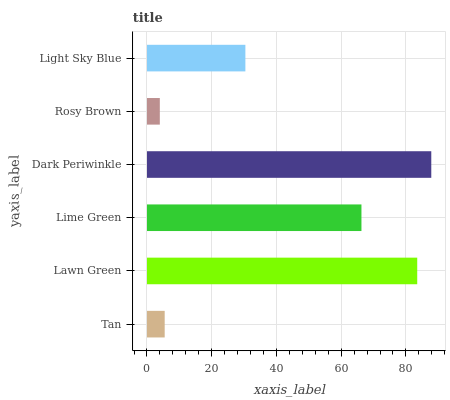Is Rosy Brown the minimum?
Answer yes or no. Yes. Is Dark Periwinkle the maximum?
Answer yes or no. Yes. Is Lawn Green the minimum?
Answer yes or no. No. Is Lawn Green the maximum?
Answer yes or no. No. Is Lawn Green greater than Tan?
Answer yes or no. Yes. Is Tan less than Lawn Green?
Answer yes or no. Yes. Is Tan greater than Lawn Green?
Answer yes or no. No. Is Lawn Green less than Tan?
Answer yes or no. No. Is Lime Green the high median?
Answer yes or no. Yes. Is Light Sky Blue the low median?
Answer yes or no. Yes. Is Tan the high median?
Answer yes or no. No. Is Lime Green the low median?
Answer yes or no. No. 